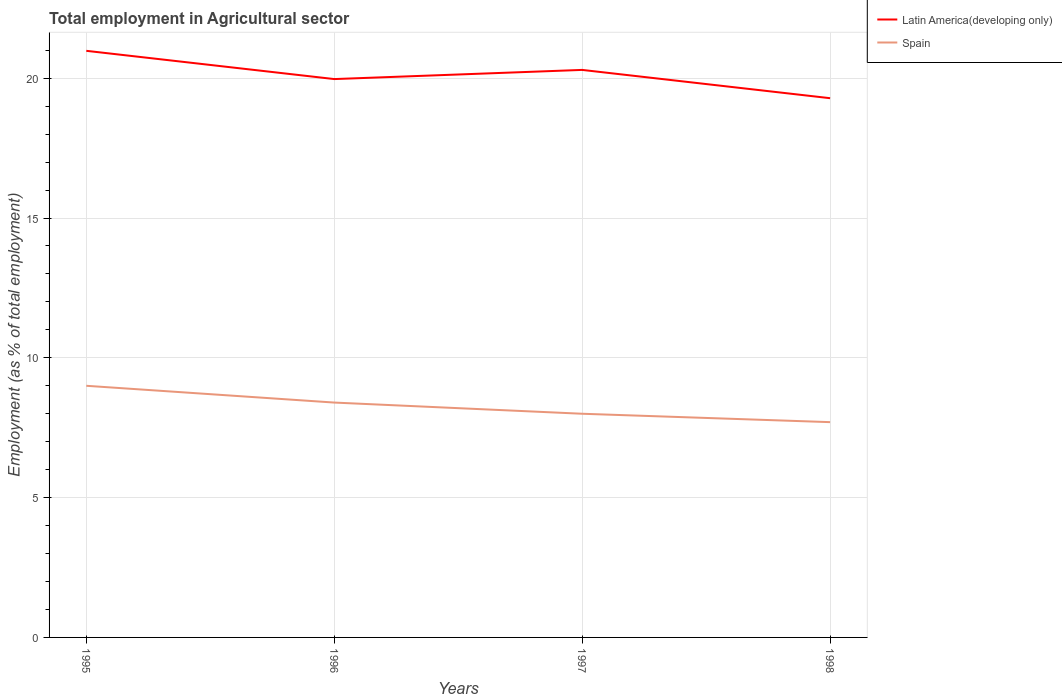How many different coloured lines are there?
Your answer should be compact. 2. Is the number of lines equal to the number of legend labels?
Provide a short and direct response. Yes. Across all years, what is the maximum employment in agricultural sector in Spain?
Make the answer very short. 7.7. In which year was the employment in agricultural sector in Latin America(developing only) maximum?
Offer a terse response. 1998. What is the total employment in agricultural sector in Spain in the graph?
Your response must be concise. 0.7. What is the difference between the highest and the second highest employment in agricultural sector in Spain?
Provide a succinct answer. 1.3. Is the employment in agricultural sector in Latin America(developing only) strictly greater than the employment in agricultural sector in Spain over the years?
Provide a succinct answer. No. How many years are there in the graph?
Ensure brevity in your answer.  4. What is the difference between two consecutive major ticks on the Y-axis?
Give a very brief answer. 5. Are the values on the major ticks of Y-axis written in scientific E-notation?
Make the answer very short. No. How are the legend labels stacked?
Keep it short and to the point. Vertical. What is the title of the graph?
Give a very brief answer. Total employment in Agricultural sector. What is the label or title of the Y-axis?
Offer a terse response. Employment (as % of total employment). What is the Employment (as % of total employment) in Latin America(developing only) in 1995?
Your answer should be compact. 20.98. What is the Employment (as % of total employment) in Latin America(developing only) in 1996?
Ensure brevity in your answer.  19.97. What is the Employment (as % of total employment) in Spain in 1996?
Make the answer very short. 8.4. What is the Employment (as % of total employment) in Latin America(developing only) in 1997?
Provide a succinct answer. 20.3. What is the Employment (as % of total employment) of Spain in 1997?
Ensure brevity in your answer.  8. What is the Employment (as % of total employment) in Latin America(developing only) in 1998?
Give a very brief answer. 19.29. What is the Employment (as % of total employment) in Spain in 1998?
Give a very brief answer. 7.7. Across all years, what is the maximum Employment (as % of total employment) in Latin America(developing only)?
Your response must be concise. 20.98. Across all years, what is the minimum Employment (as % of total employment) of Latin America(developing only)?
Your answer should be compact. 19.29. Across all years, what is the minimum Employment (as % of total employment) of Spain?
Give a very brief answer. 7.7. What is the total Employment (as % of total employment) of Latin America(developing only) in the graph?
Offer a very short reply. 80.53. What is the total Employment (as % of total employment) in Spain in the graph?
Give a very brief answer. 33.1. What is the difference between the Employment (as % of total employment) in Latin America(developing only) in 1995 and that in 1996?
Make the answer very short. 1.01. What is the difference between the Employment (as % of total employment) of Latin America(developing only) in 1995 and that in 1997?
Provide a short and direct response. 0.68. What is the difference between the Employment (as % of total employment) in Latin America(developing only) in 1995 and that in 1998?
Your response must be concise. 1.69. What is the difference between the Employment (as % of total employment) of Latin America(developing only) in 1996 and that in 1997?
Ensure brevity in your answer.  -0.33. What is the difference between the Employment (as % of total employment) in Latin America(developing only) in 1996 and that in 1998?
Offer a terse response. 0.68. What is the difference between the Employment (as % of total employment) in Spain in 1996 and that in 1998?
Offer a very short reply. 0.7. What is the difference between the Employment (as % of total employment) in Latin America(developing only) in 1997 and that in 1998?
Keep it short and to the point. 1.01. What is the difference between the Employment (as % of total employment) of Spain in 1997 and that in 1998?
Provide a short and direct response. 0.3. What is the difference between the Employment (as % of total employment) of Latin America(developing only) in 1995 and the Employment (as % of total employment) of Spain in 1996?
Keep it short and to the point. 12.58. What is the difference between the Employment (as % of total employment) in Latin America(developing only) in 1995 and the Employment (as % of total employment) in Spain in 1997?
Give a very brief answer. 12.98. What is the difference between the Employment (as % of total employment) in Latin America(developing only) in 1995 and the Employment (as % of total employment) in Spain in 1998?
Provide a succinct answer. 13.28. What is the difference between the Employment (as % of total employment) of Latin America(developing only) in 1996 and the Employment (as % of total employment) of Spain in 1997?
Give a very brief answer. 11.97. What is the difference between the Employment (as % of total employment) in Latin America(developing only) in 1996 and the Employment (as % of total employment) in Spain in 1998?
Make the answer very short. 12.27. What is the difference between the Employment (as % of total employment) in Latin America(developing only) in 1997 and the Employment (as % of total employment) in Spain in 1998?
Provide a succinct answer. 12.6. What is the average Employment (as % of total employment) of Latin America(developing only) per year?
Give a very brief answer. 20.13. What is the average Employment (as % of total employment) in Spain per year?
Keep it short and to the point. 8.28. In the year 1995, what is the difference between the Employment (as % of total employment) in Latin America(developing only) and Employment (as % of total employment) in Spain?
Provide a succinct answer. 11.98. In the year 1996, what is the difference between the Employment (as % of total employment) of Latin America(developing only) and Employment (as % of total employment) of Spain?
Offer a terse response. 11.57. In the year 1997, what is the difference between the Employment (as % of total employment) of Latin America(developing only) and Employment (as % of total employment) of Spain?
Provide a short and direct response. 12.3. In the year 1998, what is the difference between the Employment (as % of total employment) of Latin America(developing only) and Employment (as % of total employment) of Spain?
Keep it short and to the point. 11.59. What is the ratio of the Employment (as % of total employment) of Latin America(developing only) in 1995 to that in 1996?
Keep it short and to the point. 1.05. What is the ratio of the Employment (as % of total employment) in Spain in 1995 to that in 1996?
Your answer should be very brief. 1.07. What is the ratio of the Employment (as % of total employment) of Latin America(developing only) in 1995 to that in 1997?
Keep it short and to the point. 1.03. What is the ratio of the Employment (as % of total employment) in Latin America(developing only) in 1995 to that in 1998?
Provide a succinct answer. 1.09. What is the ratio of the Employment (as % of total employment) of Spain in 1995 to that in 1998?
Your answer should be compact. 1.17. What is the ratio of the Employment (as % of total employment) in Latin America(developing only) in 1996 to that in 1997?
Keep it short and to the point. 0.98. What is the ratio of the Employment (as % of total employment) in Latin America(developing only) in 1996 to that in 1998?
Make the answer very short. 1.04. What is the ratio of the Employment (as % of total employment) of Latin America(developing only) in 1997 to that in 1998?
Keep it short and to the point. 1.05. What is the ratio of the Employment (as % of total employment) of Spain in 1997 to that in 1998?
Offer a terse response. 1.04. What is the difference between the highest and the second highest Employment (as % of total employment) in Latin America(developing only)?
Ensure brevity in your answer.  0.68. What is the difference between the highest and the second highest Employment (as % of total employment) of Spain?
Provide a short and direct response. 0.6. What is the difference between the highest and the lowest Employment (as % of total employment) in Latin America(developing only)?
Keep it short and to the point. 1.69. What is the difference between the highest and the lowest Employment (as % of total employment) of Spain?
Offer a terse response. 1.3. 